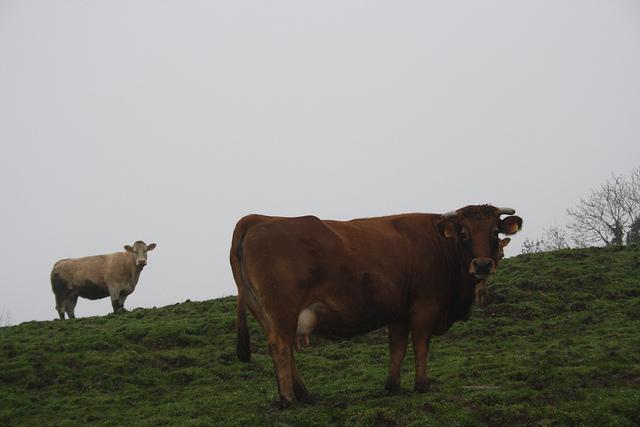Are these dairy cows?
Answer briefly. Yes. Is it daytime?
Keep it brief. Yes. Why would knitters appreciate this animal?
Keep it brief. Wool. How many cows are there?
Keep it brief. 2. Does one animal have horns?
Concise answer only. Yes. 